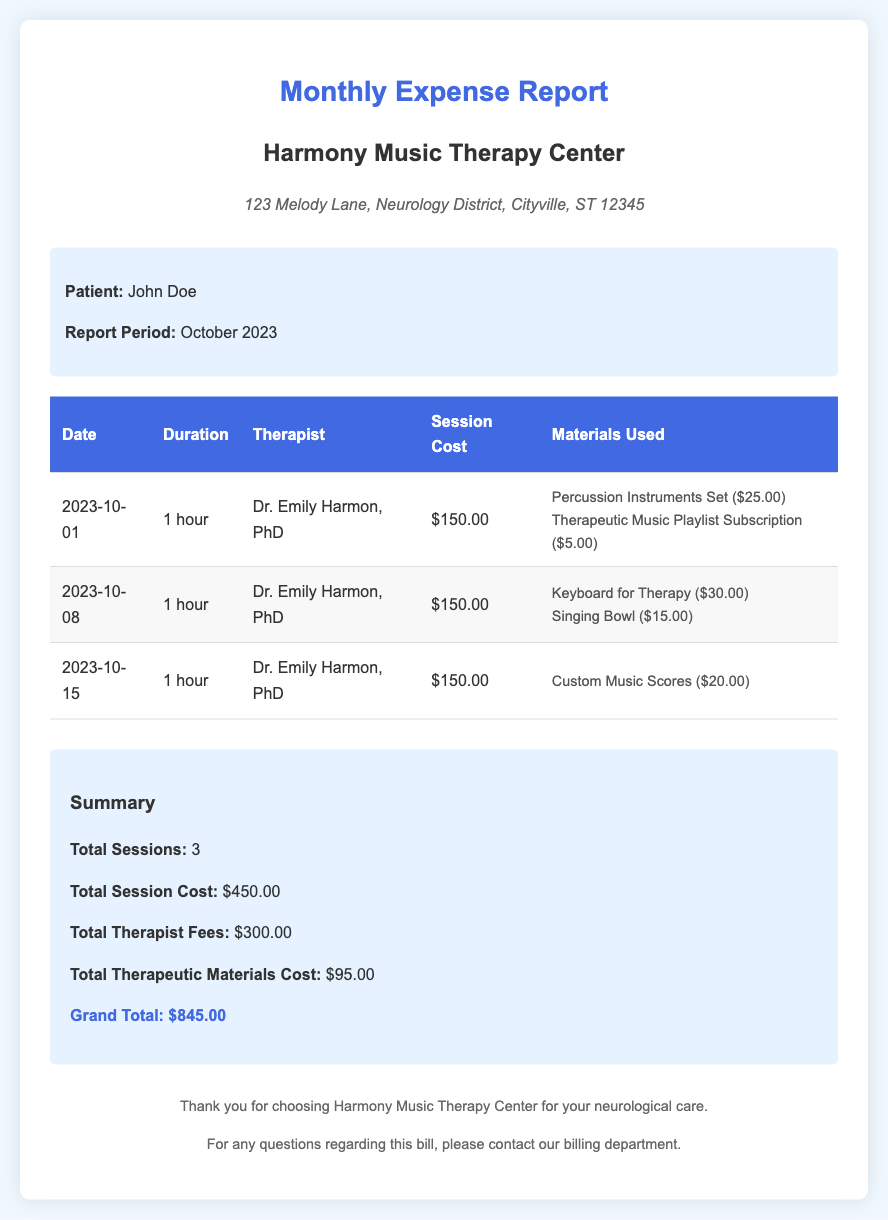What is the report period? The report period for the expenses is provided as October 2023.
Answer: October 2023 Who is the therapist? The name of the therapist who conducted the sessions is mentioned in the document.
Answer: Dr. Emily Harmon, PhD What is the total session cost? The total session cost is calculated from the cost of each session listed in the document.
Answer: $450.00 How many sessions were recorded? The document states the total number of therapy sessions held during the report period.
Answer: 3 What is the cost of the singing bowl used in the sessions? The document lists the cost of the singing bowl as part of the materials used during one of the sessions.
Answer: $15.00 What is the grand total amount due? The grand total is the sum of session costs, therapist fees, and materials costs provided in the summary section.
Answer: $845.00 What materials were used during the first session? The document details the therapeutic materials used in the first session, which are listed explicitly.
Answer: Percussion Instruments Set ($25.00), Therapeutic Music Playlist Subscription ($5.00) What is the total therapeutic materials cost? The total cost for all therapeutic materials used is provided in the summary section of the document.
Answer: $95.00 When was the last therapy session? The date of the last therapy session is mentioned in the document.
Answer: 2023-10-15 